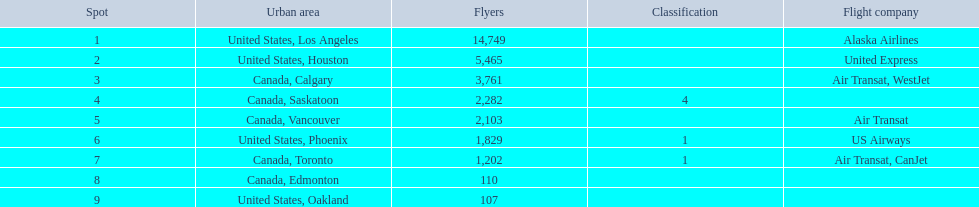What cities do the planes fly to? United States, Los Angeles, United States, Houston, Canada, Calgary, Canada, Saskatoon, Canada, Vancouver, United States, Phoenix, Canada, Toronto, Canada, Edmonton, United States, Oakland. Parse the full table. {'header': ['Spot', 'Urban area', 'Flyers', 'Classification', 'Flight company'], 'rows': [['1', 'United States, Los Angeles', '14,749', '', 'Alaska Airlines'], ['2', 'United States, Houston', '5,465', '', 'United Express'], ['3', 'Canada, Calgary', '3,761', '', 'Air Transat, WestJet'], ['4', 'Canada, Saskatoon', '2,282', '4', ''], ['5', 'Canada, Vancouver', '2,103', '', 'Air Transat'], ['6', 'United States, Phoenix', '1,829', '1', 'US Airways'], ['7', 'Canada, Toronto', '1,202', '1', 'Air Transat, CanJet'], ['8', 'Canada, Edmonton', '110', '', ''], ['9', 'United States, Oakland', '107', '', '']]} How many people are flying to phoenix, arizona? 1,829. 